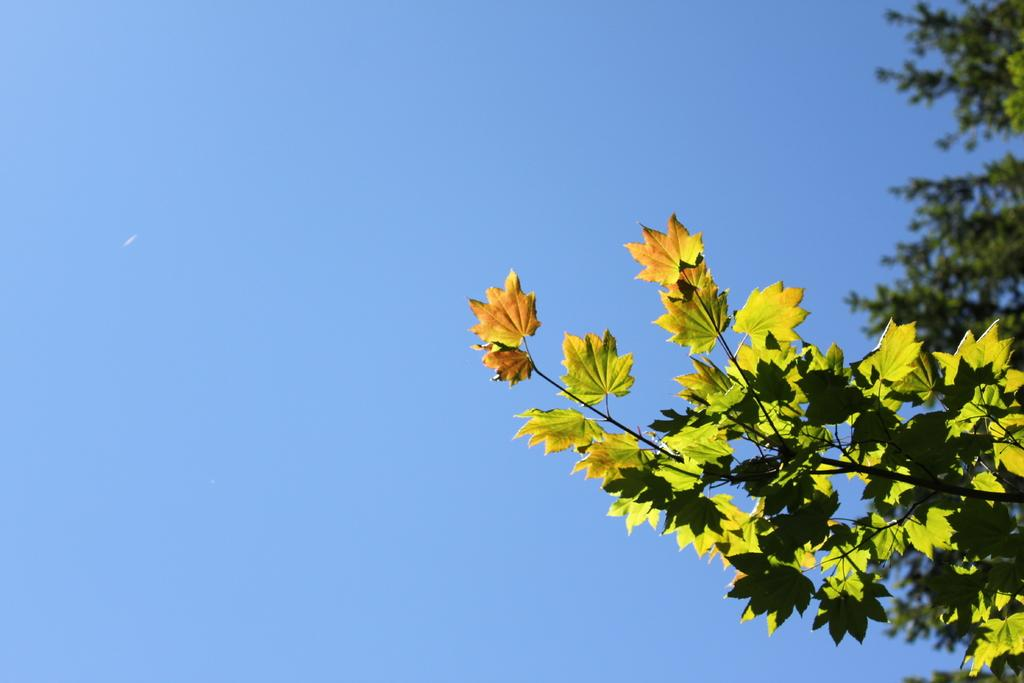What type of vegetation is on the right side of the image? There are trees on the right side of the image. What is visible in the background of the image? The sky is visible in the background of the image. What color is the sky in the image? The color of the sky is blue. Can you tell me how many bottles of wine are present in the image? There is no mention of wine or bottles in the provided facts, so it cannot be determined from the image. Is there a giraffe visible in the image? There is no giraffe present in the image; it features trees and a blue sky. 